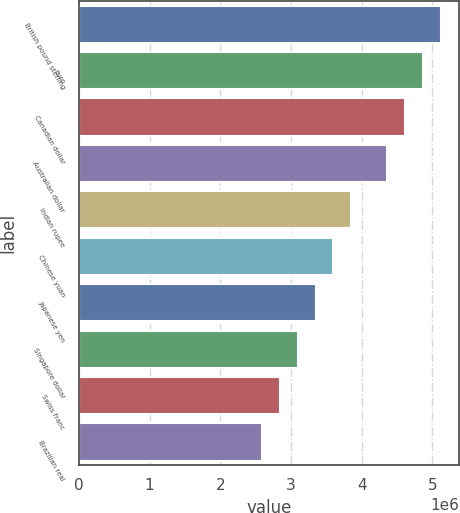Convert chart to OTSL. <chart><loc_0><loc_0><loc_500><loc_500><bar_chart><fcel>British pound sterling<fcel>euro<fcel>Canadian dollar<fcel>Australian dollar<fcel>Indian rupee<fcel>Chinese yuan<fcel>Japanese yen<fcel>Singapore dollar<fcel>Swiss franc<fcel>Brazilian real<nl><fcel>5.11879e+06<fcel>4.8656e+06<fcel>4.61241e+06<fcel>4.35922e+06<fcel>3.85284e+06<fcel>3.59965e+06<fcel>3.34646e+06<fcel>3.09327e+06<fcel>2.84008e+06<fcel>2.58689e+06<nl></chart> 